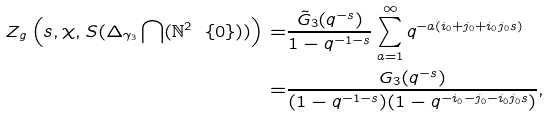Convert formula to latex. <formula><loc_0><loc_0><loc_500><loc_500>Z _ { g } \left ( s , \chi , S ( \Delta _ { \gamma _ { 3 } } \bigcap ( \mathbb { N } ^ { 2 } \ \{ 0 \} ) ) \right ) = & \frac { \tilde { G } _ { 3 } ( q ^ { - s } ) } { 1 - q ^ { - 1 - s } } \sum _ { a = 1 } ^ { \infty } q ^ { - a ( i _ { 0 } + j _ { 0 } + i _ { 0 } j _ { 0 } s ) } \\ = & \frac { G _ { 3 } ( q ^ { - s } ) } { ( 1 - q ^ { - 1 - s } ) ( 1 - q ^ { - i _ { 0 } - j _ { 0 } - i _ { 0 } j _ { 0 } s } ) } ,</formula> 